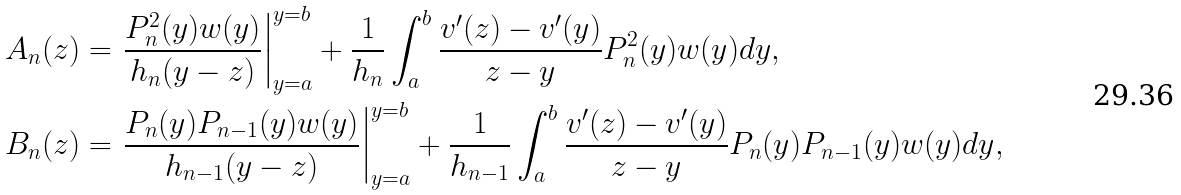<formula> <loc_0><loc_0><loc_500><loc_500>A _ { n } ( z ) & = \left . \frac { P _ { n } ^ { 2 } ( y ) w ( y ) } { h _ { n } ( y - z ) } \right | _ { y = a } ^ { y = b } + \frac { 1 } { h _ { n } } \int _ { a } ^ { b } \frac { v ^ { \prime } ( z ) - v ^ { \prime } ( y ) } { z - y } P _ { n } ^ { 2 } ( y ) w ( y ) d y , \\ B _ { n } ( z ) & = \left . \frac { P _ { n } ( y ) P _ { n - 1 } ( y ) w ( y ) } { h _ { n - 1 } ( y - z ) } \right | _ { y = a } ^ { y = b } + \frac { 1 } { h _ { n - 1 } } \int _ { a } ^ { b } \frac { v ^ { \prime } ( z ) - v ^ { \prime } ( y ) } { z - y } P _ { n } ( y ) P _ { n - 1 } ( y ) w ( y ) d y ,</formula> 